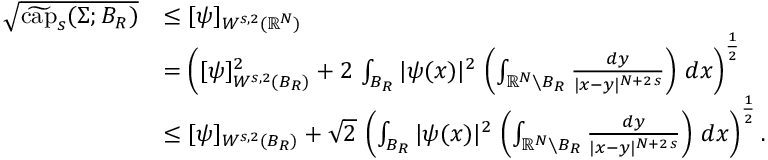<formula> <loc_0><loc_0><loc_500><loc_500>\begin{array} { r l } { \sqrt { \widetilde { c a p } _ { s } ( \Sigma ; B _ { R } ) } } & { \leq [ \psi ] _ { W ^ { s , 2 } ( \mathbb { R } ^ { N } ) } } \\ & { = \left ( [ \psi ] _ { W ^ { s , 2 } ( B _ { R } ) } ^ { 2 } + 2 \, \int _ { B _ { R } } | \psi ( x ) | ^ { 2 } \, \left ( \int _ { \mathbb { R } ^ { N } \ B _ { R } } \frac { d y } { | x - y | ^ { N + 2 \, s } } \right ) \, d x \right ) ^ { \frac { 1 } { 2 } } } \\ & { \leq [ \psi ] _ { W ^ { s , 2 } ( B _ { R } ) } + \sqrt { 2 } \, \left ( \int _ { B _ { R } } | \psi ( x ) | ^ { 2 } \, \left ( \int _ { \mathbb { R } ^ { N } \ B _ { R } } \frac { d y } { | x - y | ^ { N + 2 \, s } } \right ) \, d x \right ) ^ { \frac { 1 } { 2 } } . } \end{array}</formula> 